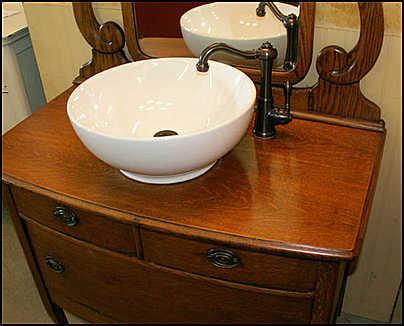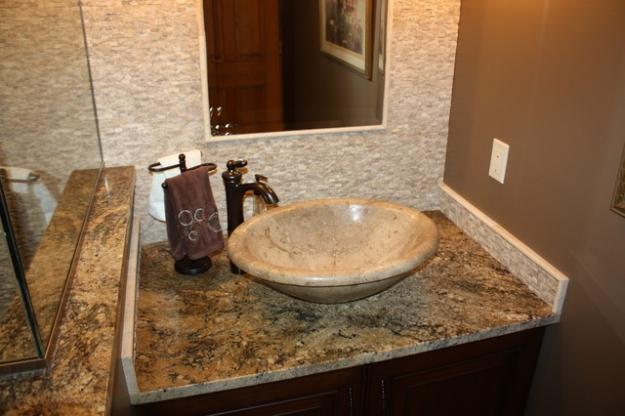The first image is the image on the left, the second image is the image on the right. For the images shown, is this caption "A mirror sits above the sink in the image on the left." true? Answer yes or no. Yes. The first image is the image on the left, the second image is the image on the right. Considering the images on both sides, is "A white sink on a wooden vanity angles up at the back to form its own backsplash and has chrome faucets with bell-shaped ends." valid? Answer yes or no. No. 